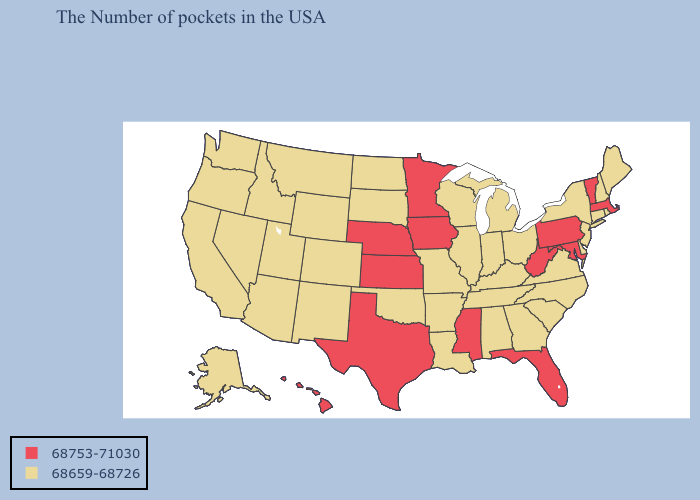Among the states that border Tennessee , does Mississippi have the lowest value?
Be succinct. No. Does Illinois have the highest value in the MidWest?
Be succinct. No. What is the value of Tennessee?
Answer briefly. 68659-68726. Name the states that have a value in the range 68659-68726?
Answer briefly. Maine, Rhode Island, New Hampshire, Connecticut, New York, New Jersey, Delaware, Virginia, North Carolina, South Carolina, Ohio, Georgia, Michigan, Kentucky, Indiana, Alabama, Tennessee, Wisconsin, Illinois, Louisiana, Missouri, Arkansas, Oklahoma, South Dakota, North Dakota, Wyoming, Colorado, New Mexico, Utah, Montana, Arizona, Idaho, Nevada, California, Washington, Oregon, Alaska. Does North Carolina have the same value as Idaho?
Write a very short answer. Yes. Among the states that border North Dakota , which have the highest value?
Give a very brief answer. Minnesota. Which states hav the highest value in the MidWest?
Short answer required. Minnesota, Iowa, Kansas, Nebraska. What is the highest value in states that border Texas?
Be succinct. 68659-68726. Name the states that have a value in the range 68659-68726?
Keep it brief. Maine, Rhode Island, New Hampshire, Connecticut, New York, New Jersey, Delaware, Virginia, North Carolina, South Carolina, Ohio, Georgia, Michigan, Kentucky, Indiana, Alabama, Tennessee, Wisconsin, Illinois, Louisiana, Missouri, Arkansas, Oklahoma, South Dakota, North Dakota, Wyoming, Colorado, New Mexico, Utah, Montana, Arizona, Idaho, Nevada, California, Washington, Oregon, Alaska. What is the value of Rhode Island?
Write a very short answer. 68659-68726. What is the value of Oklahoma?
Be succinct. 68659-68726. Name the states that have a value in the range 68659-68726?
Be succinct. Maine, Rhode Island, New Hampshire, Connecticut, New York, New Jersey, Delaware, Virginia, North Carolina, South Carolina, Ohio, Georgia, Michigan, Kentucky, Indiana, Alabama, Tennessee, Wisconsin, Illinois, Louisiana, Missouri, Arkansas, Oklahoma, South Dakota, North Dakota, Wyoming, Colorado, New Mexico, Utah, Montana, Arizona, Idaho, Nevada, California, Washington, Oregon, Alaska. Name the states that have a value in the range 68753-71030?
Short answer required. Massachusetts, Vermont, Maryland, Pennsylvania, West Virginia, Florida, Mississippi, Minnesota, Iowa, Kansas, Nebraska, Texas, Hawaii. 